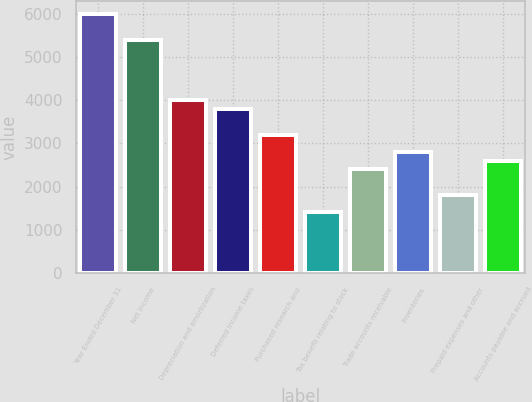<chart> <loc_0><loc_0><loc_500><loc_500><bar_chart><fcel>Year Ended December 31<fcel>Net income<fcel>Depreciation and amortization<fcel>Deferred income taxes<fcel>Purchased research and<fcel>Tax benefit relating to stock<fcel>Trade accounts receivable<fcel>Inventories<fcel>Prepaid expenses and other<fcel>Accounts payable and accrued<nl><fcel>5998<fcel>5398.6<fcel>4000<fcel>3800.2<fcel>3200.8<fcel>1402.6<fcel>2401.6<fcel>2801.2<fcel>1802.2<fcel>2601.4<nl></chart> 